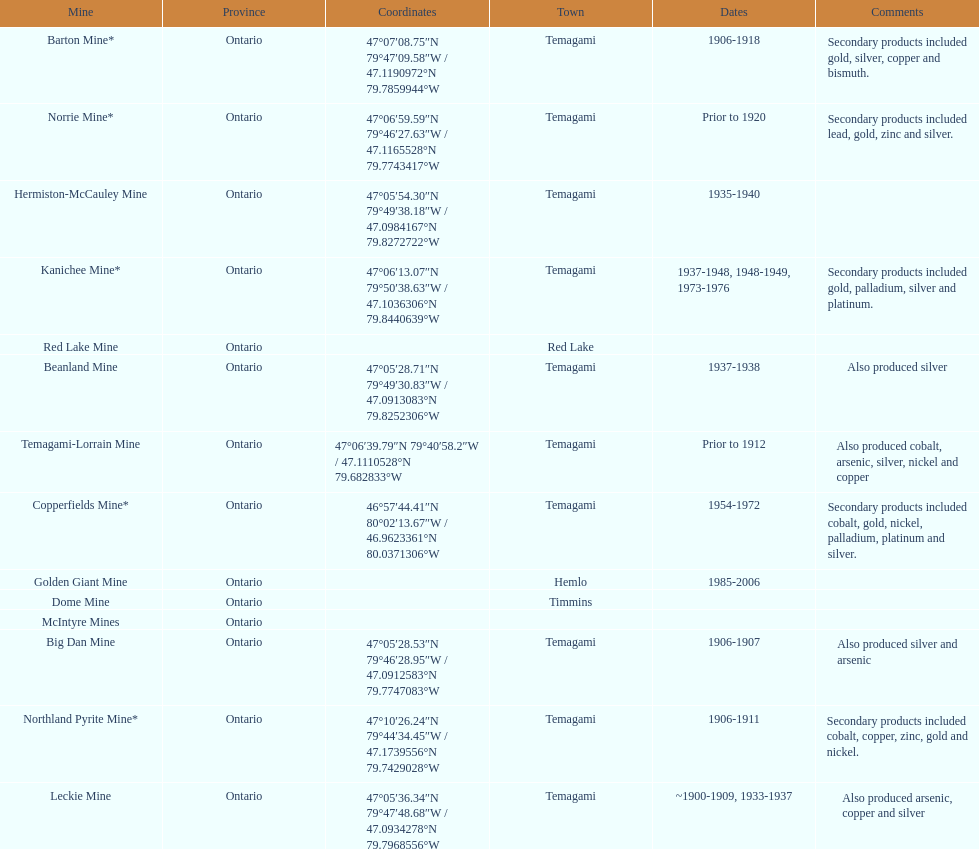What mine is in the town of timmins? Dome Mine. 